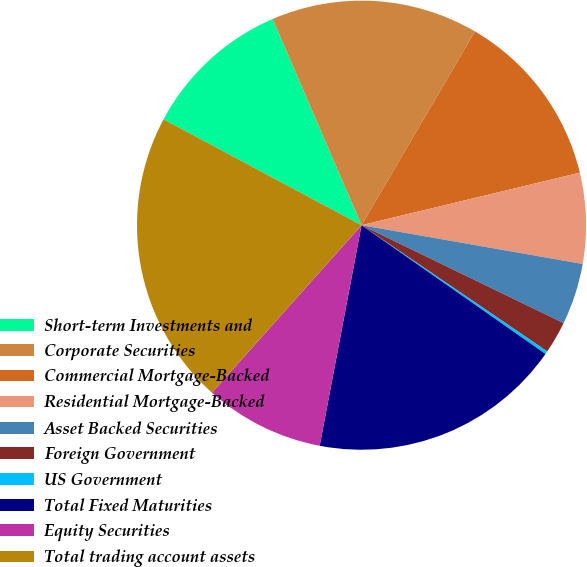Convert chart to OTSL. <chart><loc_0><loc_0><loc_500><loc_500><pie_chart><fcel>Short-term Investments and<fcel>Corporate Securities<fcel>Commercial Mortgage-Backed<fcel>Residential Mortgage-Backed<fcel>Asset Backed Securities<fcel>Foreign Government<fcel>US Government<fcel>Total Fixed Maturities<fcel>Equity Securities<fcel>Total trading account assets<nl><fcel>10.71%<fcel>14.91%<fcel>12.81%<fcel>6.52%<fcel>4.42%<fcel>2.32%<fcel>0.22%<fcel>18.26%<fcel>8.62%<fcel>21.21%<nl></chart> 